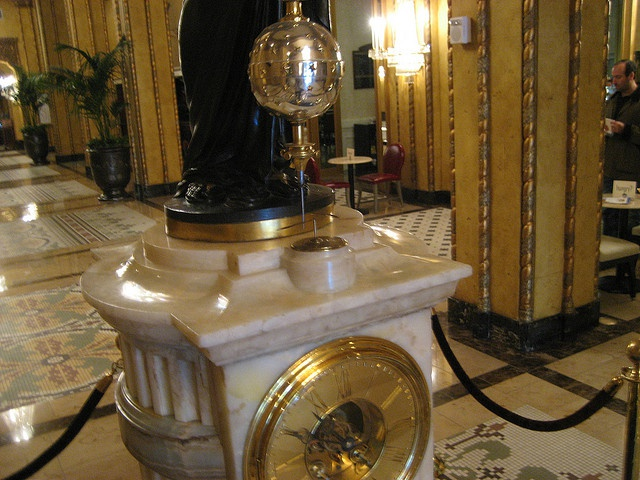Describe the objects in this image and their specific colors. I can see clock in maroon, olive, and black tones, potted plant in maroon, black, and olive tones, people in maroon, black, and gray tones, potted plant in maroon, black, olive, and gray tones, and chair in maroon, black, and gray tones in this image. 